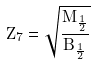<formula> <loc_0><loc_0><loc_500><loc_500>Z _ { 7 } = \sqrt { \frac { M _ { \frac { 1 } { 2 } } } { B _ { \frac { 1 } { 2 } } } }</formula> 